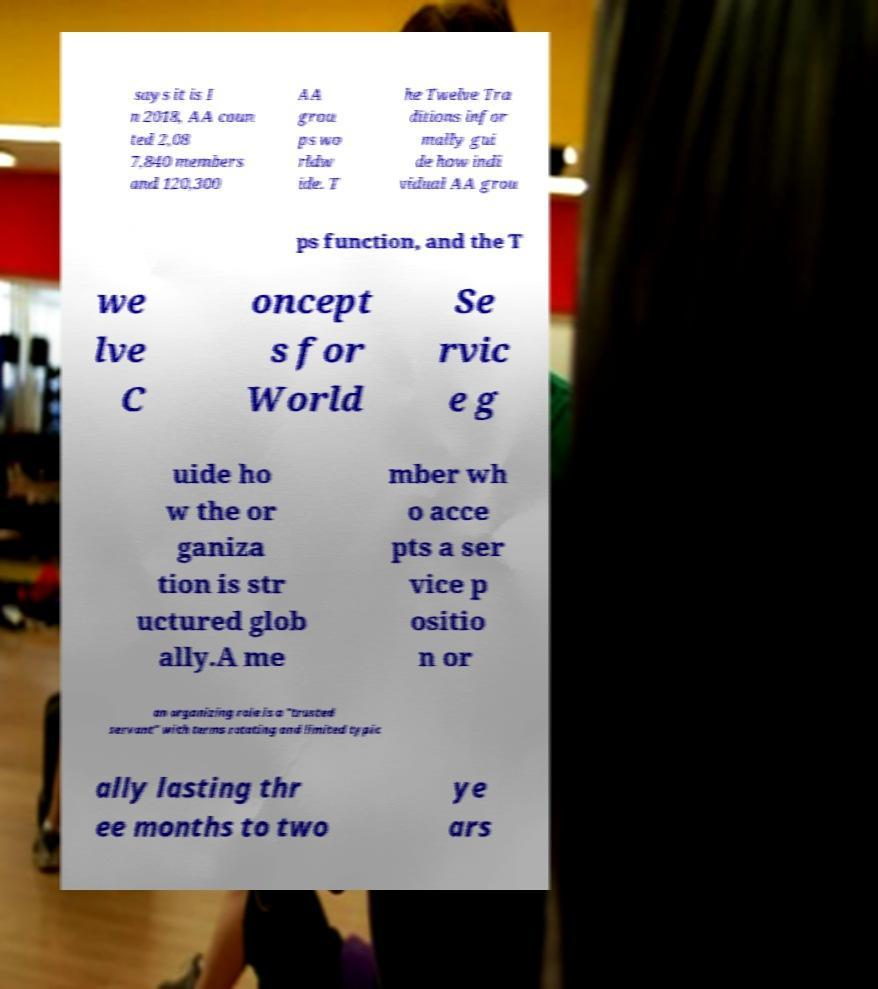Could you assist in decoding the text presented in this image and type it out clearly? says it is I n 2018, AA coun ted 2,08 7,840 members and 120,300 AA grou ps wo rldw ide. T he Twelve Tra ditions infor mally gui de how indi vidual AA grou ps function, and the T we lve C oncept s for World Se rvic e g uide ho w the or ganiza tion is str uctured glob ally.A me mber wh o acce pts a ser vice p ositio n or an organizing role is a "trusted servant" with terms rotating and limited typic ally lasting thr ee months to two ye ars 